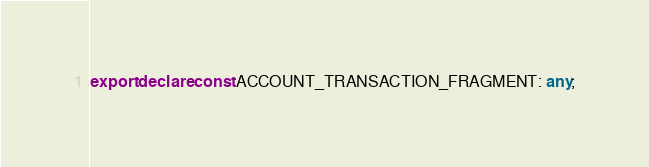<code> <loc_0><loc_0><loc_500><loc_500><_TypeScript_>export declare const ACCOUNT_TRANSACTION_FRAGMENT: any;
</code> 